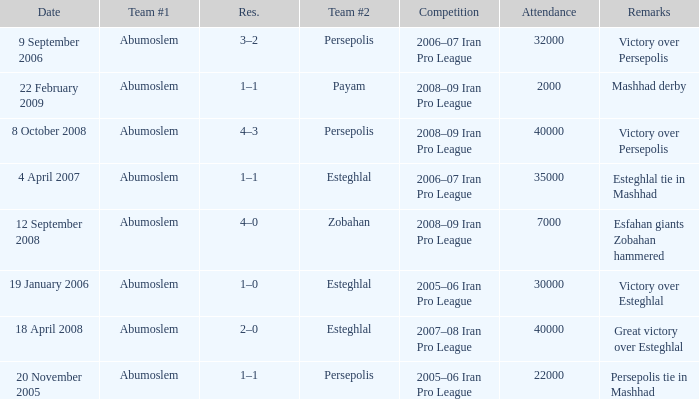What are the remarks for 8 October 2008? Victory over Persepolis. 